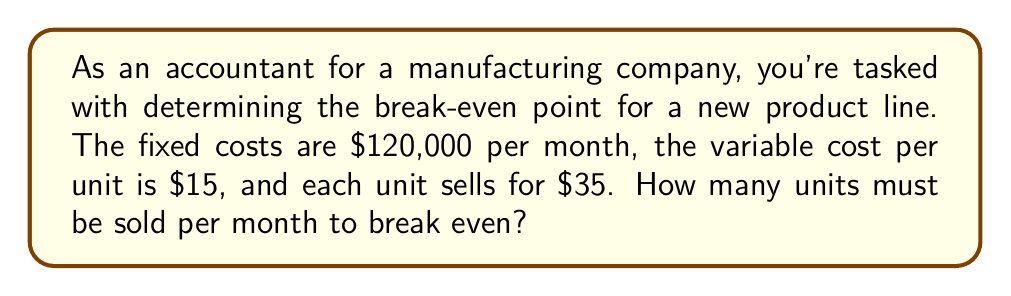Could you help me with this problem? Let's approach this step-by-step using linear equations:

1) Define variables:
   $x$ = number of units sold
   $y$ = total revenue

2) Revenue equation:
   $y = 35x$ (price per unit × number of units)

3) Cost equation:
   Total cost = Fixed costs + Variable costs
   $C = 120000 + 15x$

4) At break-even point, Revenue = Costs:
   $35x = 120000 + 15x$

5) Solve for $x$:
   $35x - 15x = 120000$
   $20x = 120000$
   $x = 120000 / 20 = 6000$

Therefore, the company needs to sell 6,000 units per month to break even.

To verify:
Revenue: $35 * 6000 = 210000$
Costs: $120000 + 15 * 6000 = 210000$

Indeed, at 6,000 units, revenue equals costs.
Answer: 6,000 units 